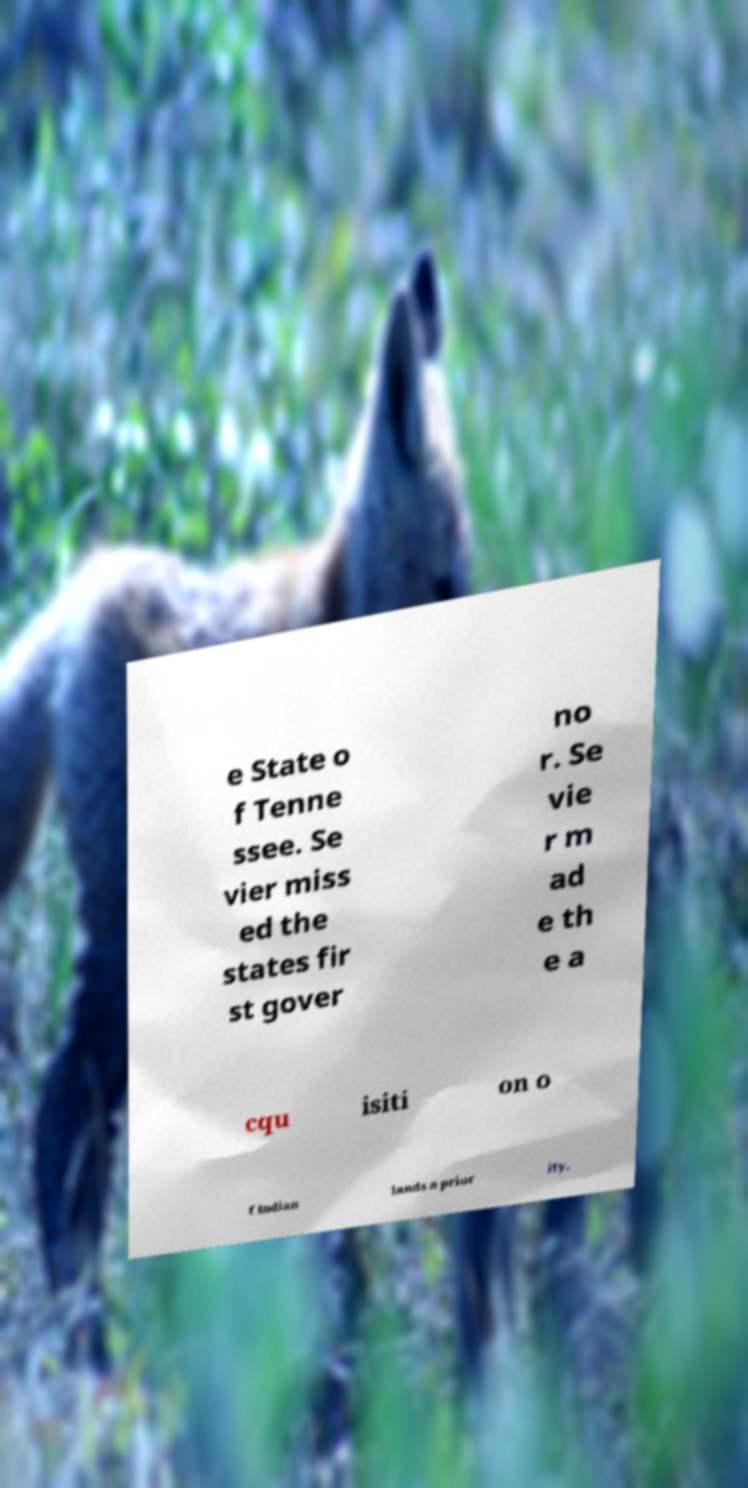Could you extract and type out the text from this image? e State o f Tenne ssee. Se vier miss ed the states fir st gover no r. Se vie r m ad e th e a cqu isiti on o f Indian lands a prior ity. 